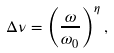Convert formula to latex. <formula><loc_0><loc_0><loc_500><loc_500>\Delta \nu = \left ( \frac { \omega } { \omega _ { 0 } } \right ) ^ { \eta } ,</formula> 